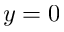<formula> <loc_0><loc_0><loc_500><loc_500>y = 0</formula> 